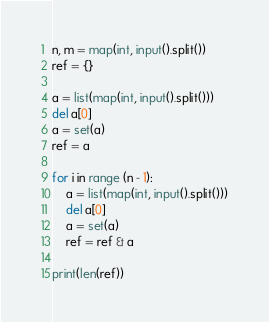<code> <loc_0><loc_0><loc_500><loc_500><_Python_>n, m = map(int, input().split())
ref = {}

a = list(map(int, input().split()))
del a[0]
a = set(a)
ref = a

for i in range (n - 1):
    a = list(map(int, input().split()))
    del a[0]
    a = set(a)
    ref = ref & a

print(len(ref))</code> 